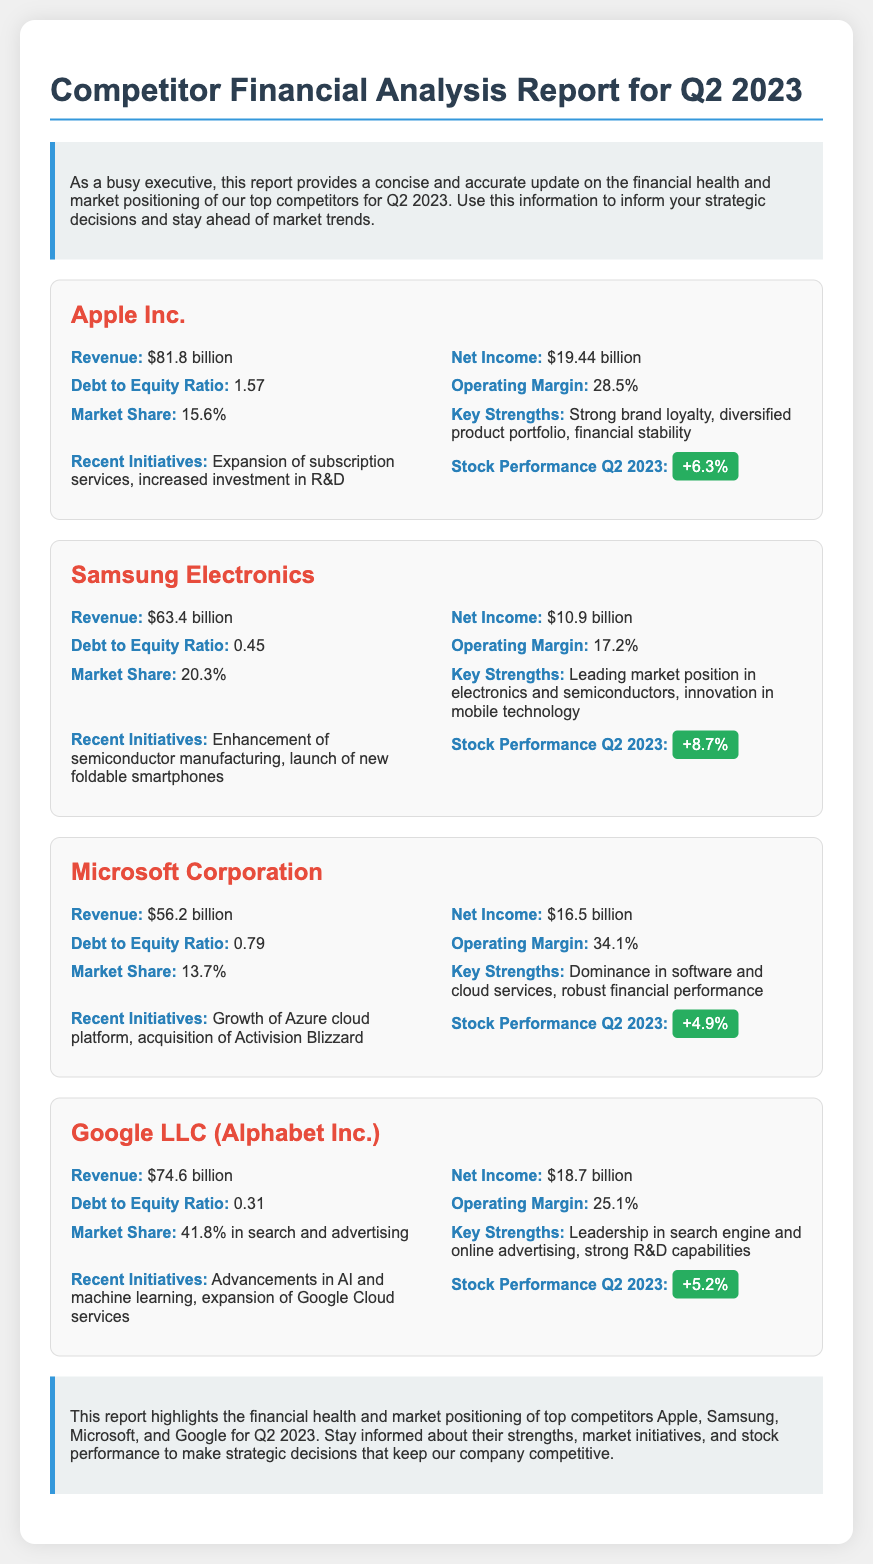What was Apple Inc.'s revenue for Q2 2023? The revenue for Apple Inc. in Q2 2023 is specifically stated in the document.
Answer: $81.8 billion What is the net income reported for Samsung Electronics? The net income for Samsung Electronics is mentioned directly in the financial health section of the document.
Answer: $10.9 billion What is the debt to equity ratio for Google LLC? The debt to equity ratio for Google LLC is provided as a specific metric in the financial health section.
Answer: 0.31 Which competitor has the highest operating margin? By comparing the operating margins of the competitors listed, we see that Microsoft has the highest.
Answer: 34.1% What key strength is associated with Apple Inc.? Each competitor has listed key strengths, and for Apple Inc., one of them is highlighted in the market positioning section.
Answer: Strong brand loyalty What recent initiative was mentioned for Microsoft Corporation? A specific recent initiative for Microsoft is listed in the market positioning part of the document.
Answer: Acquisition of Activision Blizzard What is the stock performance percentage for Samsung Electronics in Q2 2023? This information can be found under the market positioning section for Samsung Electronics.
Answer: +8.7% Which company has a market share of 41.8%? The document explicitly states the market share for Google LLC in the market positioning section.
Answer: Google LLC (Alphabet Inc.) What is the revenue for Microsoft Corporation in Q2 2023? The revenue figure for Microsoft Corporation is provided in the financial health section.
Answer: $56.2 billion 